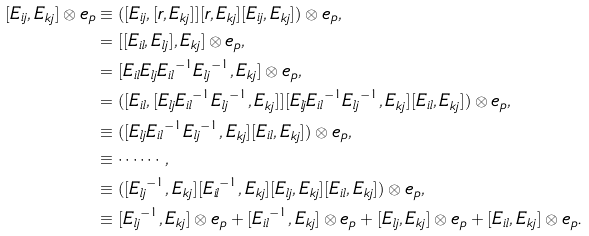<formula> <loc_0><loc_0><loc_500><loc_500>[ E _ { i j } , E _ { k j } ] \otimes e _ { p } & \equiv ( [ E _ { i j } , [ r , E _ { k j } ] ] [ r , E _ { k j } ] [ E _ { i j } , E _ { k j } ] ) \otimes e _ { p } , \\ & = [ [ E _ { i l } , E _ { l j } ] , E _ { k j } ] \otimes e _ { p } , \\ & = [ E _ { i l } E _ { l j } { E _ { i l } } ^ { - 1 } { E _ { l j } } ^ { - 1 } , E _ { k j } ] \otimes e _ { p } , \\ & = ( [ E _ { i l } , [ E _ { l j } { E _ { i l } } ^ { - 1 } { E _ { l j } } ^ { - 1 } , E _ { k j } ] ] [ E _ { l j } { E _ { i l } } ^ { - 1 } { E _ { l j } } ^ { - 1 } , E _ { k j } ] [ E _ { i l } , E _ { k j } ] ) \otimes e _ { p } , \\ & \equiv ( [ E _ { l j } { E _ { i l } } ^ { - 1 } { E _ { l j } } ^ { - 1 } , E _ { k j } ] [ E _ { i l } , E _ { k j } ] ) \otimes e _ { p } , \\ & \equiv \cdots \cdots , \\ & \equiv ( [ { E _ { l j } } ^ { - 1 } , E _ { k j } ] [ { E _ { i l } } ^ { - 1 } , E _ { k j } ] [ E _ { l j } , E _ { k j } ] [ E _ { i l } , E _ { k j } ] ) \otimes e _ { p } , \\ & \equiv [ { E _ { l j } } ^ { - 1 } , E _ { k j } ] \otimes e _ { p } + [ { E _ { i l } } ^ { - 1 } , E _ { k j } ] \otimes e _ { p } + [ E _ { l j } , E _ { k j } ] \otimes e _ { p } + [ E _ { i l } , E _ { k j } ] \otimes e _ { p } .</formula> 